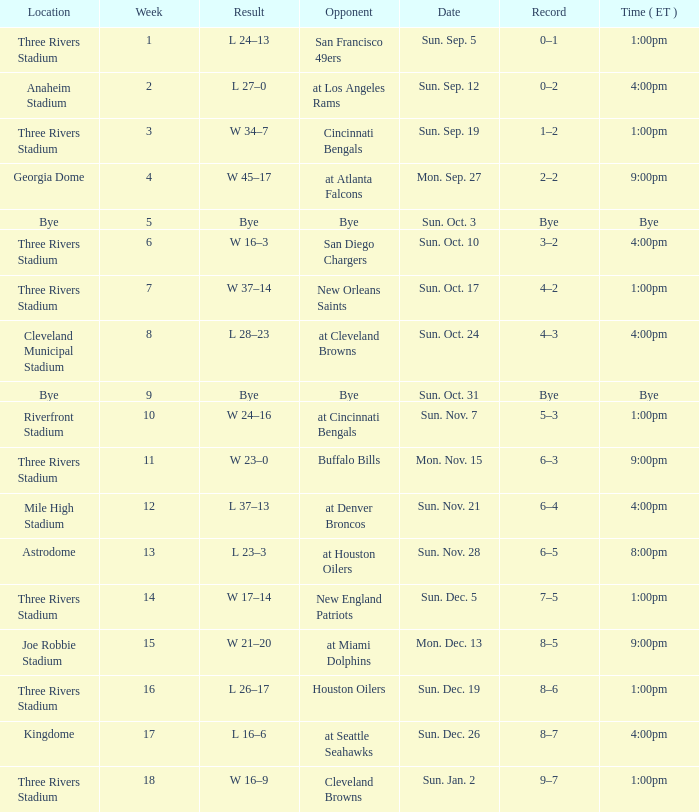What week that shows a game record of 0–1? 1.0. 